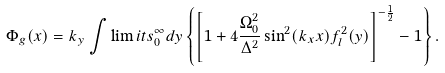Convert formula to latex. <formula><loc_0><loc_0><loc_500><loc_500>\Phi _ { g } ( x ) = k _ { y } \int \lim i t s _ { 0 } ^ { \infty } d y \left \{ \left [ 1 + 4 \frac { \Omega _ { 0 } ^ { 2 } } { \Delta ^ { 2 } } \sin ^ { 2 } ( k _ { x } x ) f _ { l } ^ { 2 } ( y ) \right ] ^ { - \frac { 1 } { 2 } } - 1 \right \} .</formula> 